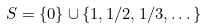<formula> <loc_0><loc_0><loc_500><loc_500>S = \{ 0 \} \cup \{ 1 , 1 / 2 , 1 / 3 , \dots \}</formula> 